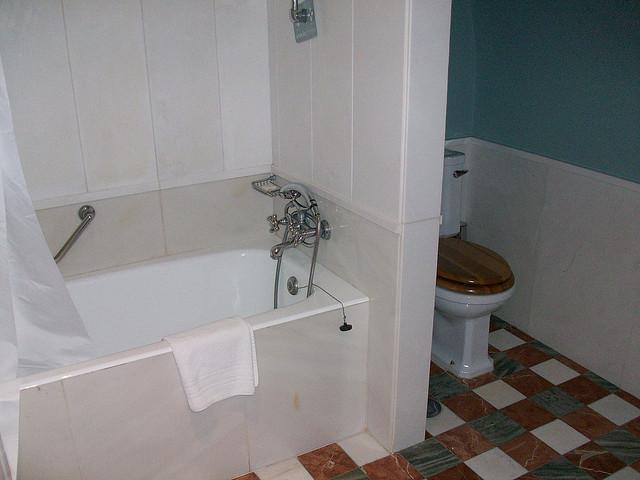How many bars are there?
Give a very brief answer. 1. How many giraffes are in the picture?
Give a very brief answer. 0. 